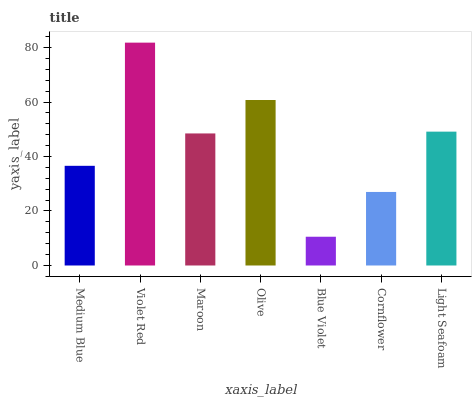Is Blue Violet the minimum?
Answer yes or no. Yes. Is Violet Red the maximum?
Answer yes or no. Yes. Is Maroon the minimum?
Answer yes or no. No. Is Maroon the maximum?
Answer yes or no. No. Is Violet Red greater than Maroon?
Answer yes or no. Yes. Is Maroon less than Violet Red?
Answer yes or no. Yes. Is Maroon greater than Violet Red?
Answer yes or no. No. Is Violet Red less than Maroon?
Answer yes or no. No. Is Maroon the high median?
Answer yes or no. Yes. Is Maroon the low median?
Answer yes or no. Yes. Is Light Seafoam the high median?
Answer yes or no. No. Is Blue Violet the low median?
Answer yes or no. No. 